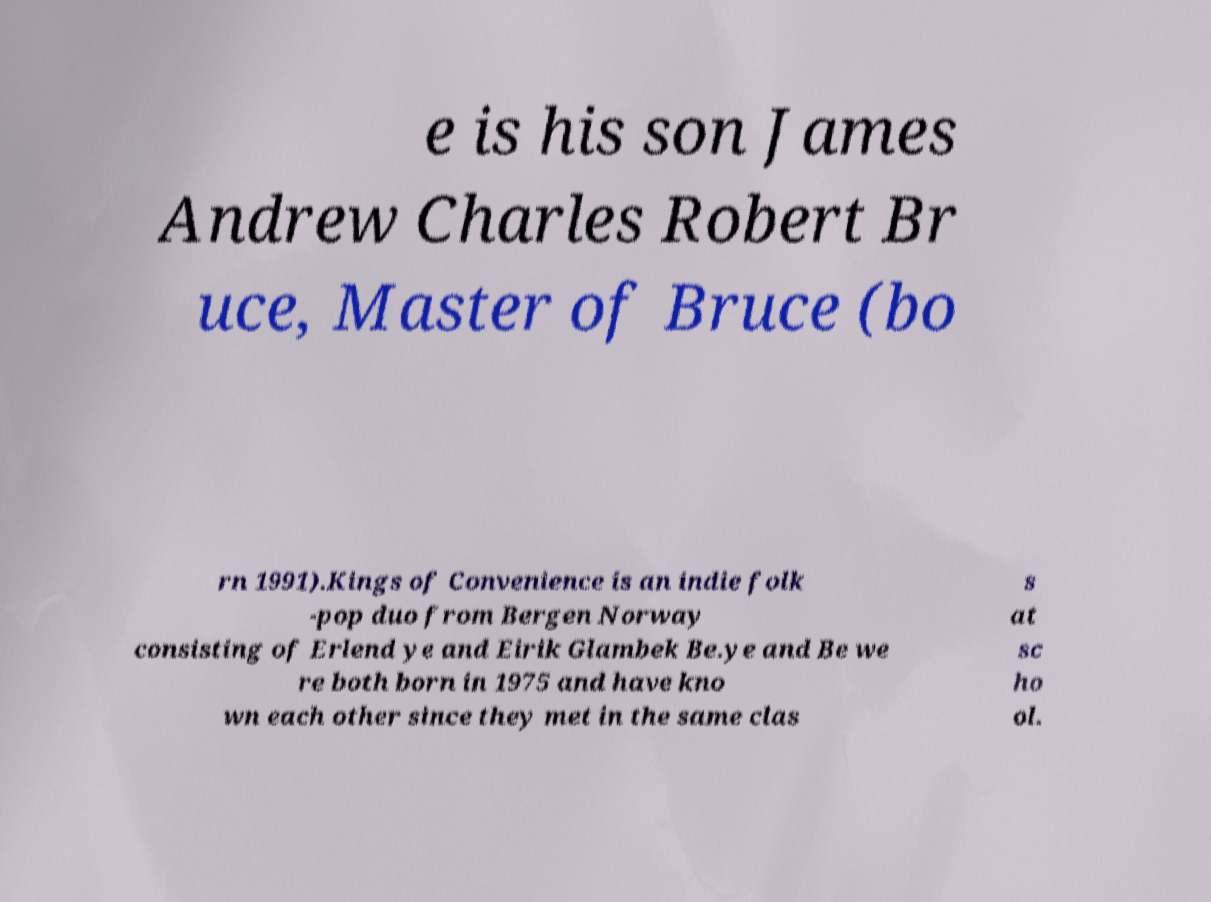For documentation purposes, I need the text within this image transcribed. Could you provide that? e is his son James Andrew Charles Robert Br uce, Master of Bruce (bo rn 1991).Kings of Convenience is an indie folk -pop duo from Bergen Norway consisting of Erlend ye and Eirik Glambek Be.ye and Be we re both born in 1975 and have kno wn each other since they met in the same clas s at sc ho ol. 